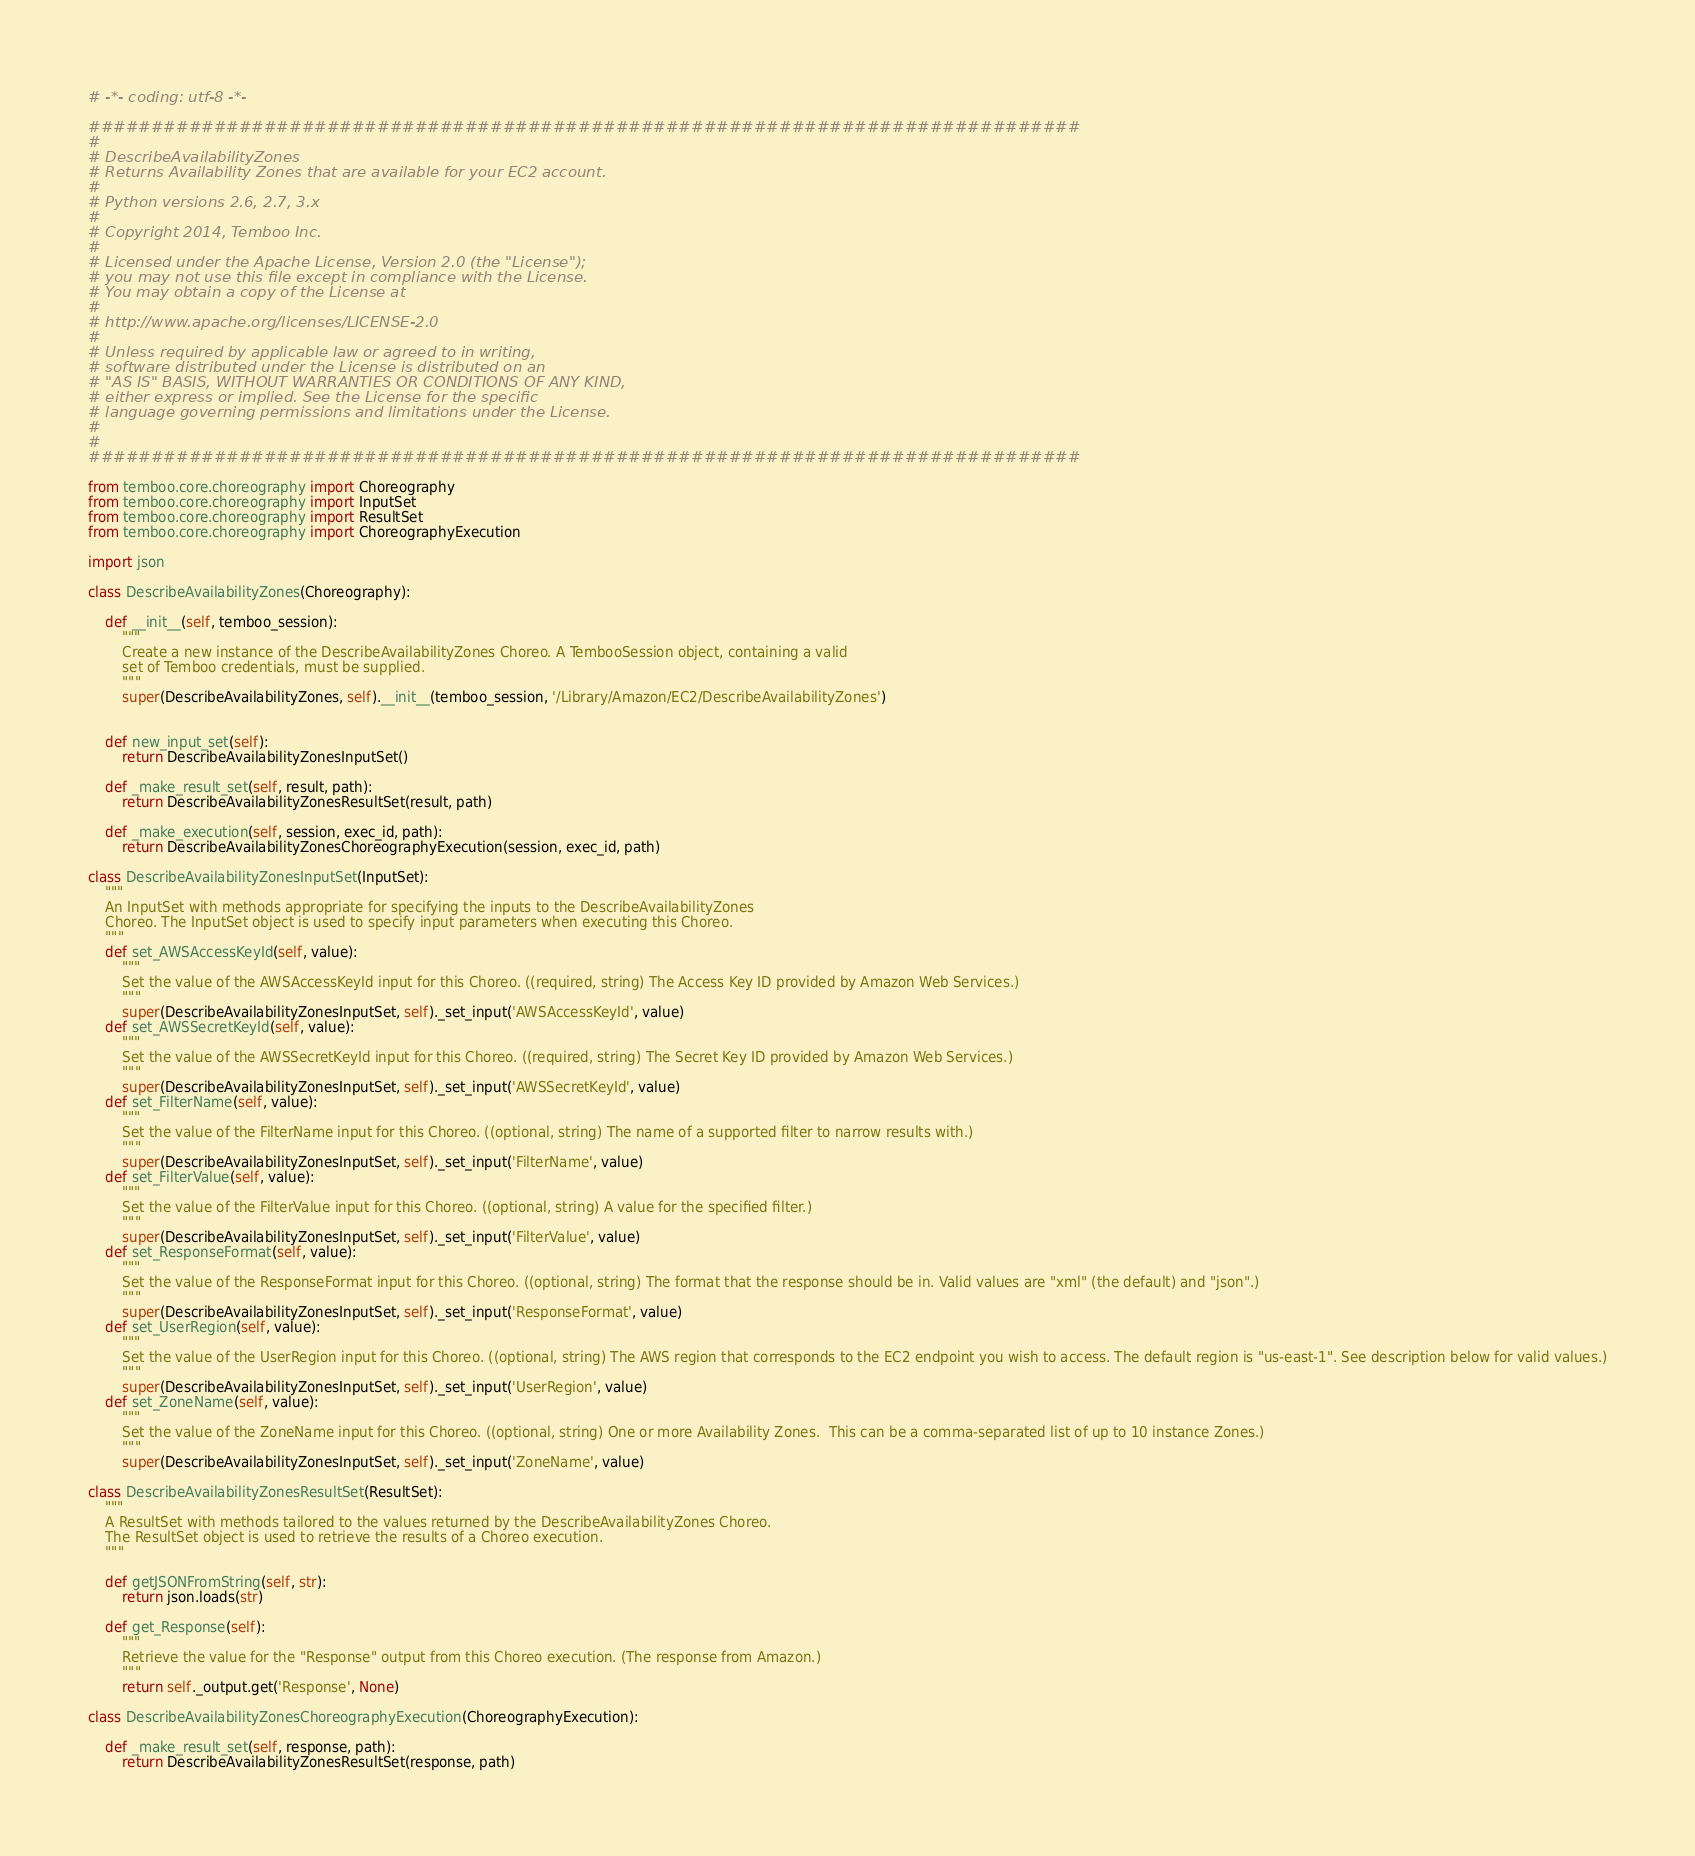<code> <loc_0><loc_0><loc_500><loc_500><_Python_># -*- coding: utf-8 -*-

###############################################################################
#
# DescribeAvailabilityZones
# Returns Availability Zones that are available for your EC2 account.
#
# Python versions 2.6, 2.7, 3.x
#
# Copyright 2014, Temboo Inc.
#
# Licensed under the Apache License, Version 2.0 (the "License");
# you may not use this file except in compliance with the License.
# You may obtain a copy of the License at
#
# http://www.apache.org/licenses/LICENSE-2.0
#
# Unless required by applicable law or agreed to in writing,
# software distributed under the License is distributed on an
# "AS IS" BASIS, WITHOUT WARRANTIES OR CONDITIONS OF ANY KIND,
# either express or implied. See the License for the specific
# language governing permissions and limitations under the License.
#
#
###############################################################################

from temboo.core.choreography import Choreography
from temboo.core.choreography import InputSet
from temboo.core.choreography import ResultSet
from temboo.core.choreography import ChoreographyExecution

import json

class DescribeAvailabilityZones(Choreography):

    def __init__(self, temboo_session):
        """
        Create a new instance of the DescribeAvailabilityZones Choreo. A TembooSession object, containing a valid
        set of Temboo credentials, must be supplied.
        """
        super(DescribeAvailabilityZones, self).__init__(temboo_session, '/Library/Amazon/EC2/DescribeAvailabilityZones')


    def new_input_set(self):
        return DescribeAvailabilityZonesInputSet()

    def _make_result_set(self, result, path):
        return DescribeAvailabilityZonesResultSet(result, path)

    def _make_execution(self, session, exec_id, path):
        return DescribeAvailabilityZonesChoreographyExecution(session, exec_id, path)

class DescribeAvailabilityZonesInputSet(InputSet):
    """
    An InputSet with methods appropriate for specifying the inputs to the DescribeAvailabilityZones
    Choreo. The InputSet object is used to specify input parameters when executing this Choreo.
    """
    def set_AWSAccessKeyId(self, value):
        """
        Set the value of the AWSAccessKeyId input for this Choreo. ((required, string) The Access Key ID provided by Amazon Web Services.)
        """
        super(DescribeAvailabilityZonesInputSet, self)._set_input('AWSAccessKeyId', value)
    def set_AWSSecretKeyId(self, value):
        """
        Set the value of the AWSSecretKeyId input for this Choreo. ((required, string) The Secret Key ID provided by Amazon Web Services.)
        """
        super(DescribeAvailabilityZonesInputSet, self)._set_input('AWSSecretKeyId', value)
    def set_FilterName(self, value):
        """
        Set the value of the FilterName input for this Choreo. ((optional, string) The name of a supported filter to narrow results with.)
        """
        super(DescribeAvailabilityZonesInputSet, self)._set_input('FilterName', value)
    def set_FilterValue(self, value):
        """
        Set the value of the FilterValue input for this Choreo. ((optional, string) A value for the specified filter.)
        """
        super(DescribeAvailabilityZonesInputSet, self)._set_input('FilterValue', value)
    def set_ResponseFormat(self, value):
        """
        Set the value of the ResponseFormat input for this Choreo. ((optional, string) The format that the response should be in. Valid values are "xml" (the default) and "json".)
        """
        super(DescribeAvailabilityZonesInputSet, self)._set_input('ResponseFormat', value)
    def set_UserRegion(self, value):
        """
        Set the value of the UserRegion input for this Choreo. ((optional, string) The AWS region that corresponds to the EC2 endpoint you wish to access. The default region is "us-east-1". See description below for valid values.)
        """
        super(DescribeAvailabilityZonesInputSet, self)._set_input('UserRegion', value)
    def set_ZoneName(self, value):
        """
        Set the value of the ZoneName input for this Choreo. ((optional, string) One or more Availability Zones.  This can be a comma-separated list of up to 10 instance Zones.)
        """
        super(DescribeAvailabilityZonesInputSet, self)._set_input('ZoneName', value)

class DescribeAvailabilityZonesResultSet(ResultSet):
    """
    A ResultSet with methods tailored to the values returned by the DescribeAvailabilityZones Choreo.
    The ResultSet object is used to retrieve the results of a Choreo execution.
    """

    def getJSONFromString(self, str):
        return json.loads(str)

    def get_Response(self):
        """
        Retrieve the value for the "Response" output from this Choreo execution. (The response from Amazon.)
        """
        return self._output.get('Response', None)

class DescribeAvailabilityZonesChoreographyExecution(ChoreographyExecution):

    def _make_result_set(self, response, path):
        return DescribeAvailabilityZonesResultSet(response, path)
</code> 